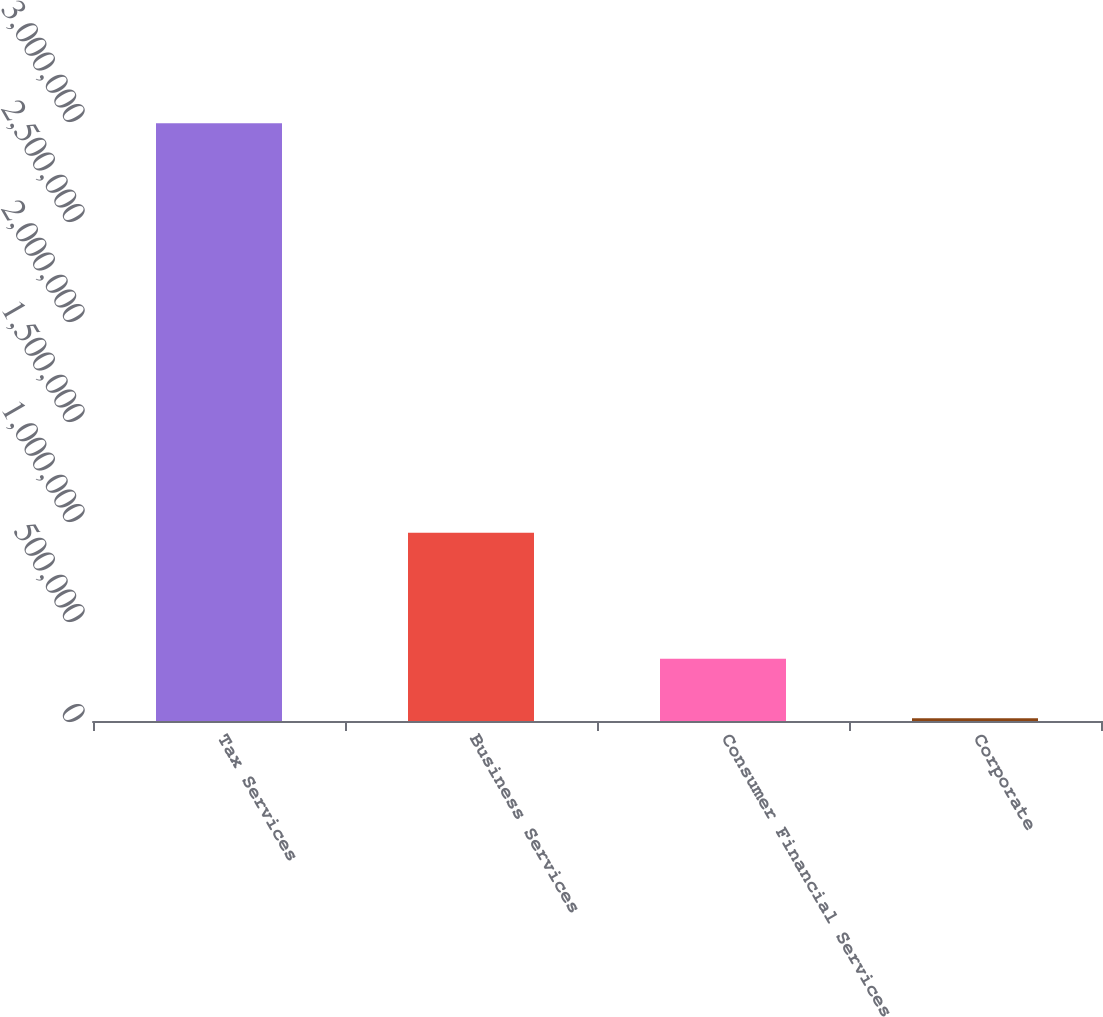Convert chart to OTSL. <chart><loc_0><loc_0><loc_500><loc_500><bar_chart><fcel>Tax Services<fcel>Business Services<fcel>Consumer Financial Services<fcel>Corporate<nl><fcel>2.98862e+06<fcel>941686<fcel>311121<fcel>13621<nl></chart> 